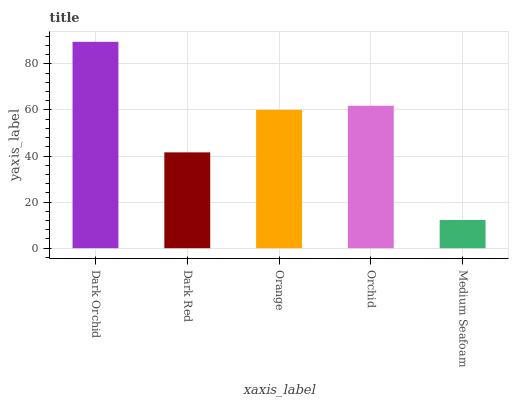Is Medium Seafoam the minimum?
Answer yes or no. Yes. Is Dark Orchid the maximum?
Answer yes or no. Yes. Is Dark Red the minimum?
Answer yes or no. No. Is Dark Red the maximum?
Answer yes or no. No. Is Dark Orchid greater than Dark Red?
Answer yes or no. Yes. Is Dark Red less than Dark Orchid?
Answer yes or no. Yes. Is Dark Red greater than Dark Orchid?
Answer yes or no. No. Is Dark Orchid less than Dark Red?
Answer yes or no. No. Is Orange the high median?
Answer yes or no. Yes. Is Orange the low median?
Answer yes or no. Yes. Is Dark Red the high median?
Answer yes or no. No. Is Orchid the low median?
Answer yes or no. No. 